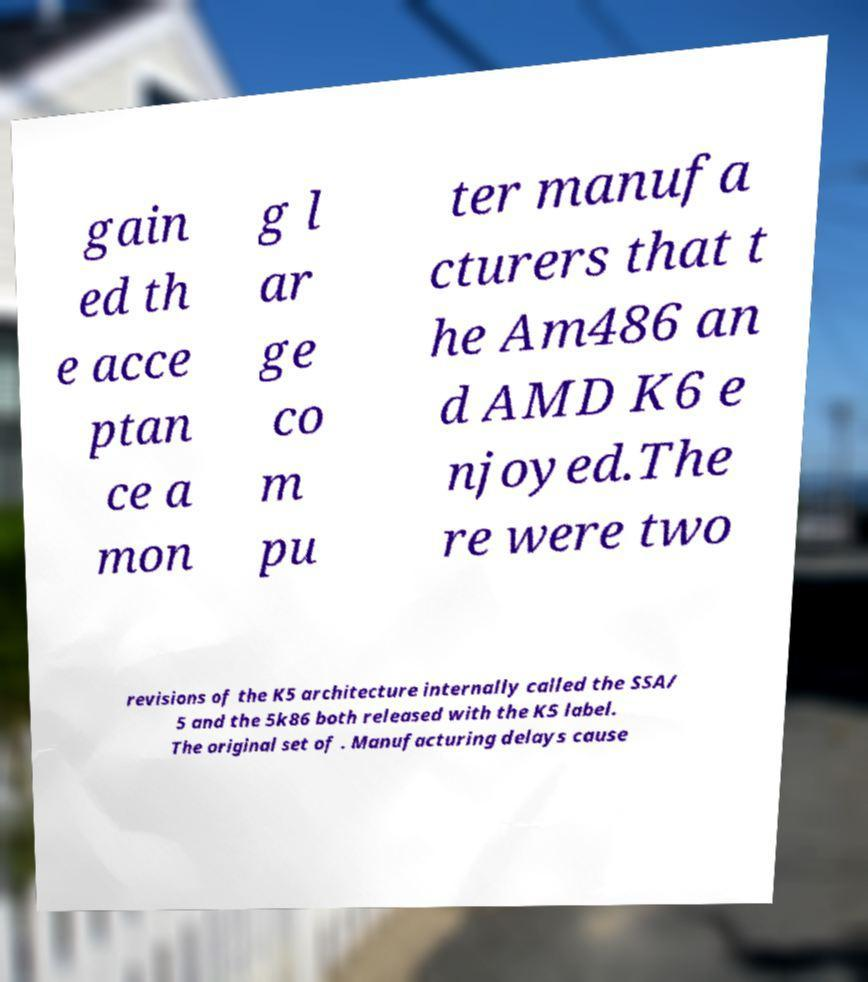Could you extract and type out the text from this image? gain ed th e acce ptan ce a mon g l ar ge co m pu ter manufa cturers that t he Am486 an d AMD K6 e njoyed.The re were two revisions of the K5 architecture internally called the SSA/ 5 and the 5k86 both released with the K5 label. The original set of . Manufacturing delays cause 